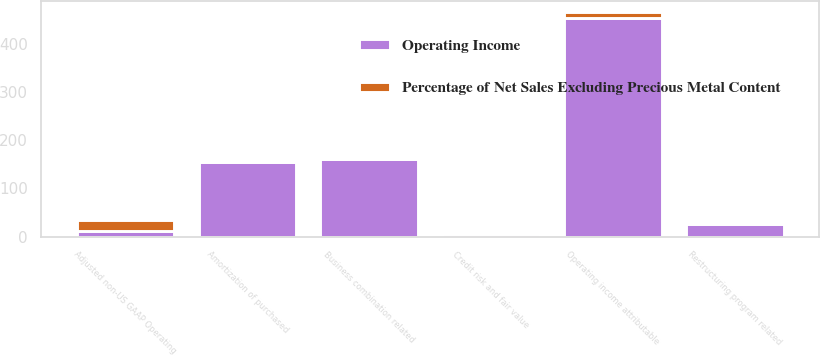Convert chart. <chart><loc_0><loc_0><loc_500><loc_500><stacked_bar_chart><ecel><fcel>Operating income attributable<fcel>Business combination related<fcel>Amortization of purchased<fcel>Restructuring program related<fcel>Credit risk and fair value<fcel>Adjusted non-US GAAP Operating<nl><fcel>Operating Income<fcel>454.7<fcel>161.8<fcel>155.3<fcel>27.1<fcel>5.3<fcel>12.4<nl><fcel>Percentage of Net Sales Excluding Precious Metal Content<fcel>12.4<fcel>4.4<fcel>4.2<fcel>0.7<fcel>0.1<fcel>21.8<nl></chart> 